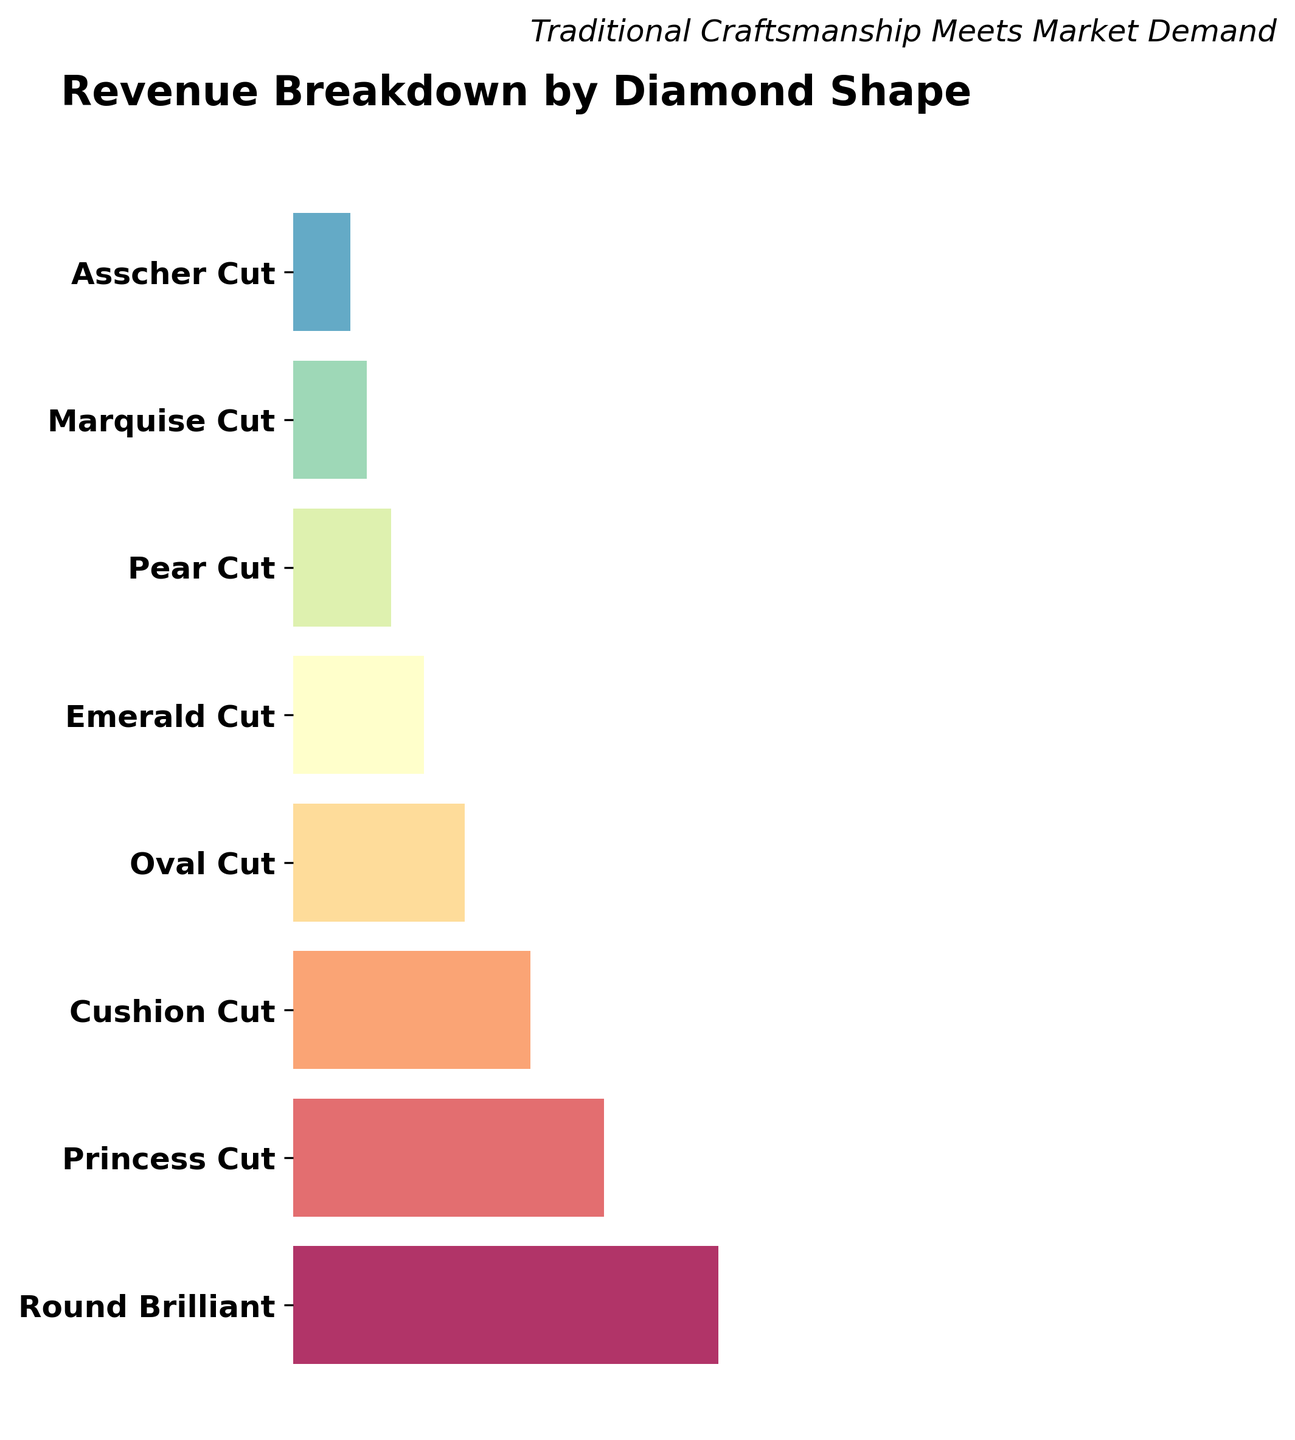What is the title of this figure? The title is usually displayed at the top of the figure. In this case, it reads 'Revenue Breakdown by Diamond Shape'.
Answer: Revenue Breakdown by Diamond Shape How many diamond shape categories are displayed in the figure? Count the number of segments or labels along the y-axis, each representing a diamond shape category. In this figure, there are eight categories listed from top to bottom.
Answer: Eight categories Which diamond shape category generates the highest revenue? Look for the widest horizontal segment which represents the largest revenue value. The 'Round Brilliant' diamond shape is the widest, indicating it generates the highest revenue.
Answer: Round Brilliant How much revenue does the 'Oval Cut' category generate? Identify the 'Oval Cut' label and find the revenue figure associated with it. The figure indicates that the 'Oval Cut' generates $2,100,000 in revenue.
Answer: $2,100,000 What is the combined revenue of the 'Asscher Cut' and 'Marquise Cut'? Sum up the revenues for the 'Asscher Cut' and 'Marquise Cut' categories by adding $700,000 and $900,000.
Answer: $1,600,000 Which category is the third highest in terms of revenue? Order the categories from highest to lowest based on their widths. The third widest segment is 'Cushion Cut' with a revenue figure of $2,900,000.
Answer: Cushion Cut What percentage of the total revenue is generated by the 'Princess Cut' category? First, find the total revenue by summing up all revenue figures. Then, calculate the percentage of 'Princess Cut' revenue ($3,800,000) over the total revenue. The total revenue is $17,100,000. Percentage is calculated as ($3,800,000 / $17,100,000) * 100 ≈ 22.22%.
Answer: 22.22% Which diamond shape has a narrower revenue segment than the 'Emerald Cut' but wider than the 'Asscher Cut'? Compare the widths of the segments visually. The 'Pear Cut' segment is narrower than 'Emerald Cut' but wider than 'Asscher Cut'.
Answer: Pear Cut 